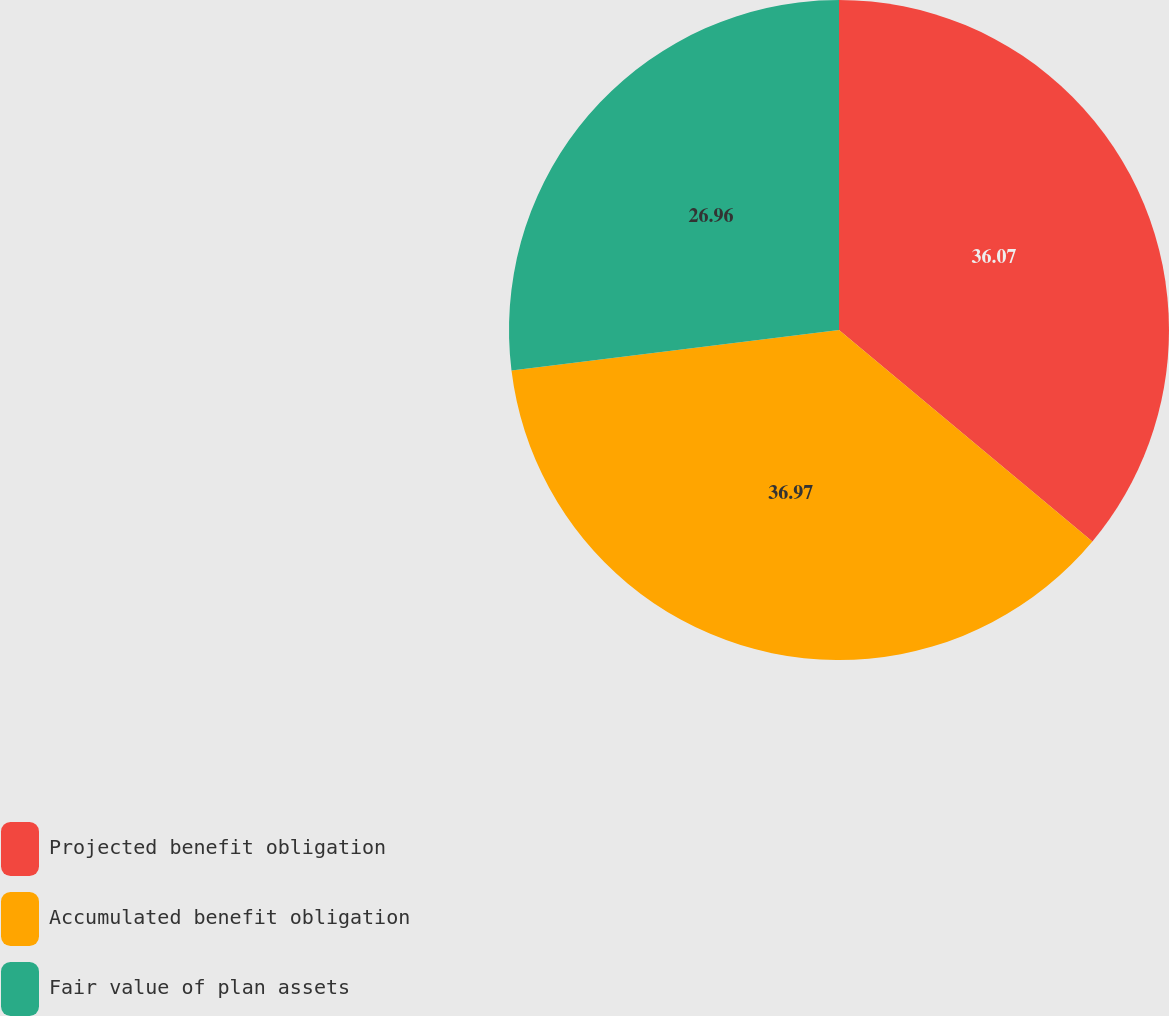Convert chart to OTSL. <chart><loc_0><loc_0><loc_500><loc_500><pie_chart><fcel>Projected benefit obligation<fcel>Accumulated benefit obligation<fcel>Fair value of plan assets<nl><fcel>36.07%<fcel>36.98%<fcel>26.96%<nl></chart> 